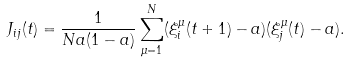Convert formula to latex. <formula><loc_0><loc_0><loc_500><loc_500>J _ { i j } ( t ) = \frac { 1 } { N { a ( 1 - a ) } } \sum _ { \mu = 1 } ^ { N } ( \xi _ { i } ^ { \mu } ( t + 1 ) - a ) ( \xi _ { j } ^ { \mu } ( t ) - a ) .</formula> 